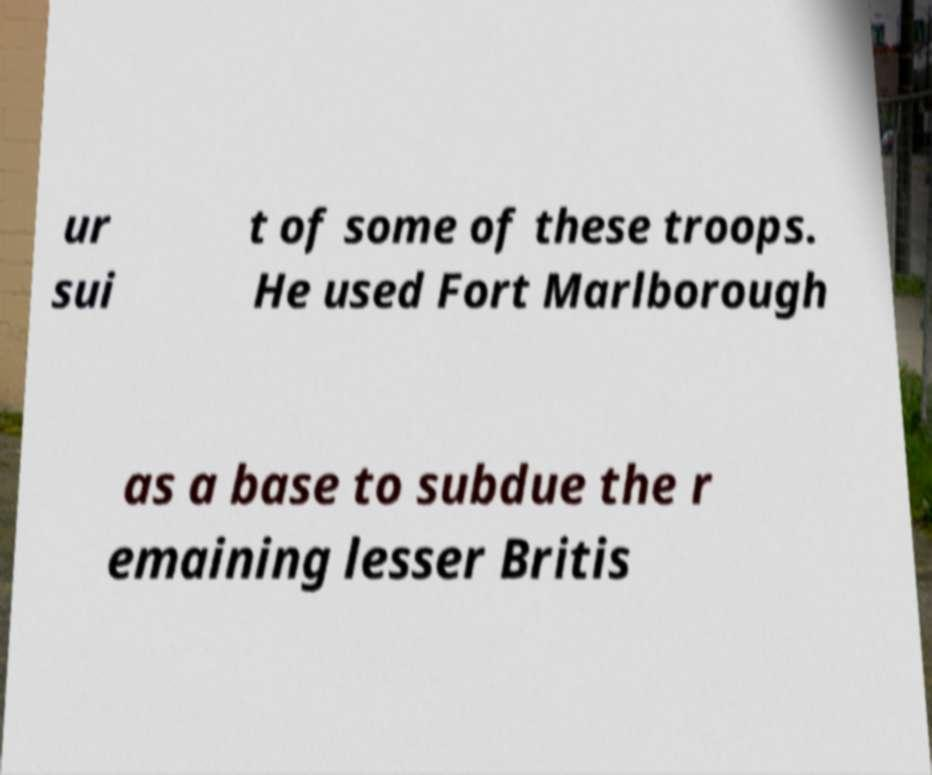Can you accurately transcribe the text from the provided image for me? ur sui t of some of these troops. He used Fort Marlborough as a base to subdue the r emaining lesser Britis 